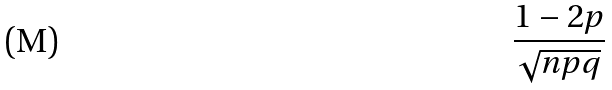Convert formula to latex. <formula><loc_0><loc_0><loc_500><loc_500>\frac { 1 - 2 p } { \sqrt { n p q } }</formula> 